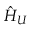Convert formula to latex. <formula><loc_0><loc_0><loc_500><loc_500>\hat { H } _ { U }</formula> 